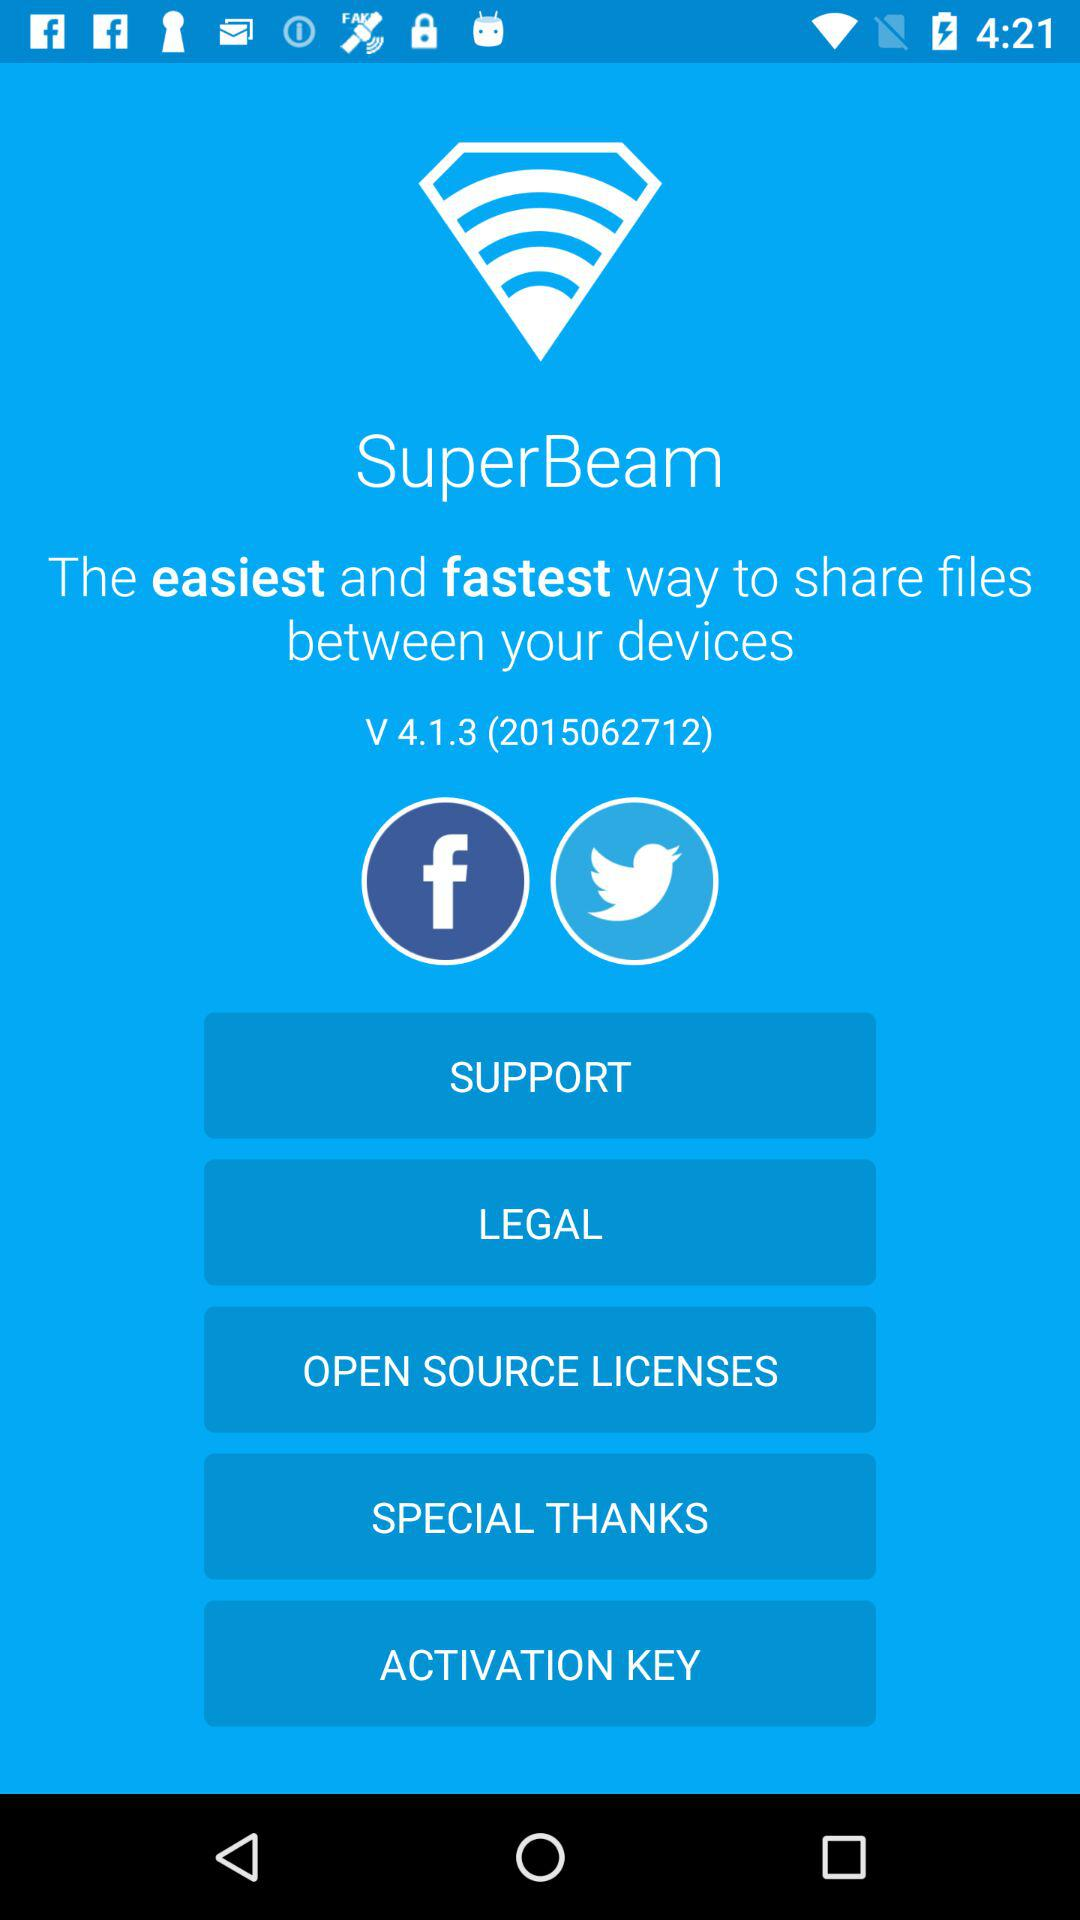Through what applications can users share files? The users can share files through "Facebook" and "Twitter". 